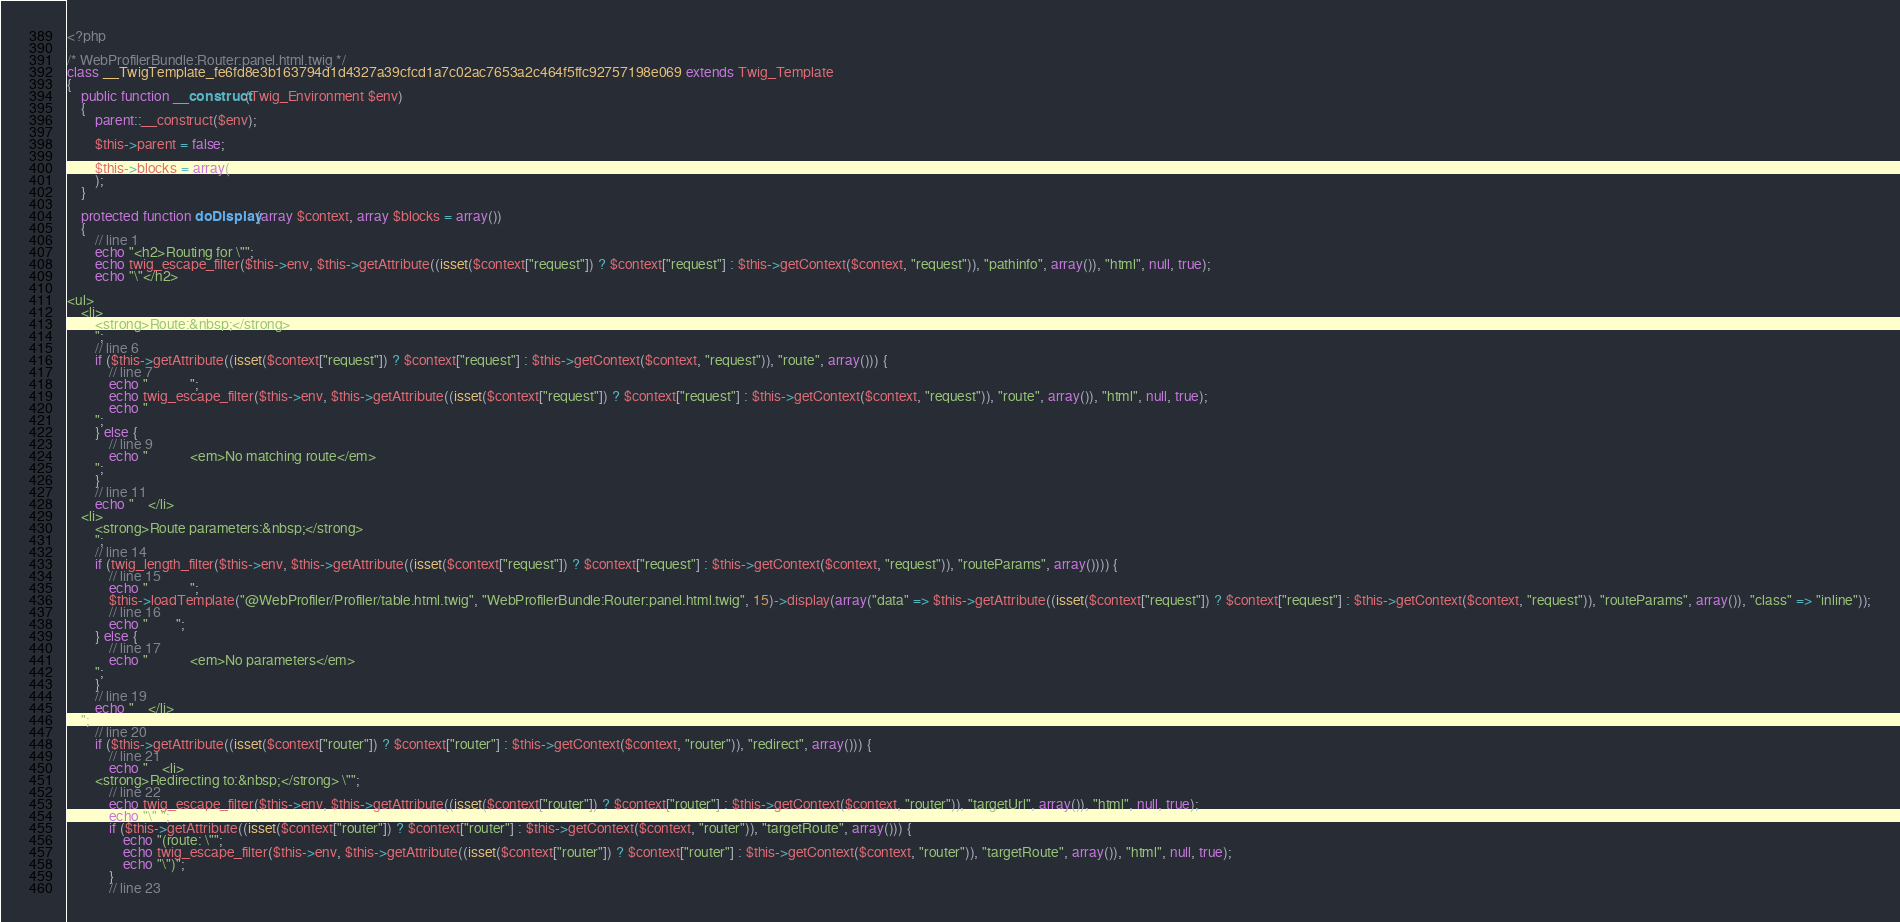<code> <loc_0><loc_0><loc_500><loc_500><_PHP_><?php

/* WebProfilerBundle:Router:panel.html.twig */
class __TwigTemplate_fe6fd8e3b163794d1d4327a39cfcd1a7c02ac7653a2c464f5ffc92757198e069 extends Twig_Template
{
    public function __construct(Twig_Environment $env)
    {
        parent::__construct($env);

        $this->parent = false;

        $this->blocks = array(
        );
    }

    protected function doDisplay(array $context, array $blocks = array())
    {
        // line 1
        echo "<h2>Routing for \"";
        echo twig_escape_filter($this->env, $this->getAttribute((isset($context["request"]) ? $context["request"] : $this->getContext($context, "request")), "pathinfo", array()), "html", null, true);
        echo "\"</h2>

<ul>
    <li>
        <strong>Route:&nbsp;</strong>
        ";
        // line 6
        if ($this->getAttribute((isset($context["request"]) ? $context["request"] : $this->getContext($context, "request")), "route", array())) {
            // line 7
            echo "            ";
            echo twig_escape_filter($this->env, $this->getAttribute((isset($context["request"]) ? $context["request"] : $this->getContext($context, "request")), "route", array()), "html", null, true);
            echo "
        ";
        } else {
            // line 9
            echo "            <em>No matching route</em>
        ";
        }
        // line 11
        echo "    </li>
    <li>
        <strong>Route parameters:&nbsp;</strong>
        ";
        // line 14
        if (twig_length_filter($this->env, $this->getAttribute((isset($context["request"]) ? $context["request"] : $this->getContext($context, "request")), "routeParams", array()))) {
            // line 15
            echo "            ";
            $this->loadTemplate("@WebProfiler/Profiler/table.html.twig", "WebProfilerBundle:Router:panel.html.twig", 15)->display(array("data" => $this->getAttribute((isset($context["request"]) ? $context["request"] : $this->getContext($context, "request")), "routeParams", array()), "class" => "inline"));
            // line 16
            echo "        ";
        } else {
            // line 17
            echo "            <em>No parameters</em>
        ";
        }
        // line 19
        echo "    </li>
    ";
        // line 20
        if ($this->getAttribute((isset($context["router"]) ? $context["router"] : $this->getContext($context, "router")), "redirect", array())) {
            // line 21
            echo "    <li>
        <strong>Redirecting to:&nbsp;</strong> \"";
            // line 22
            echo twig_escape_filter($this->env, $this->getAttribute((isset($context["router"]) ? $context["router"] : $this->getContext($context, "router")), "targetUrl", array()), "html", null, true);
            echo "\" ";
            if ($this->getAttribute((isset($context["router"]) ? $context["router"] : $this->getContext($context, "router")), "targetRoute", array())) {
                echo "(route: \"";
                echo twig_escape_filter($this->env, $this->getAttribute((isset($context["router"]) ? $context["router"] : $this->getContext($context, "router")), "targetRoute", array()), "html", null, true);
                echo "\")";
            }
            // line 23</code> 